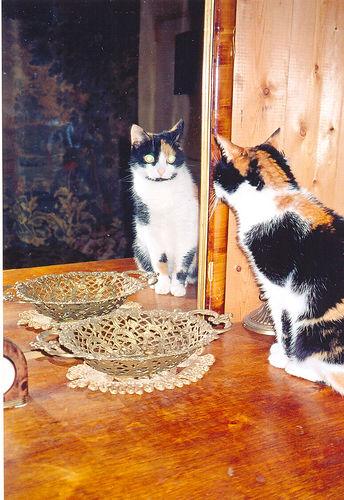What is the cat looking at?
Quick response, please. Himself. How many colors is the cat?
Concise answer only. 3. What is the cat sitting on?
Short answer required. Table. 